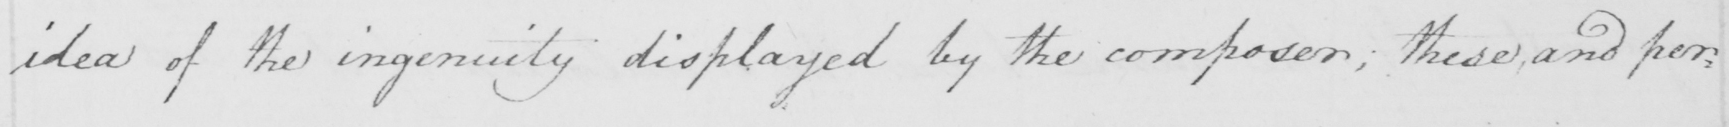Transcribe the text shown in this historical manuscript line. idea of the ingenuity displayed by the composer ; these and per : 